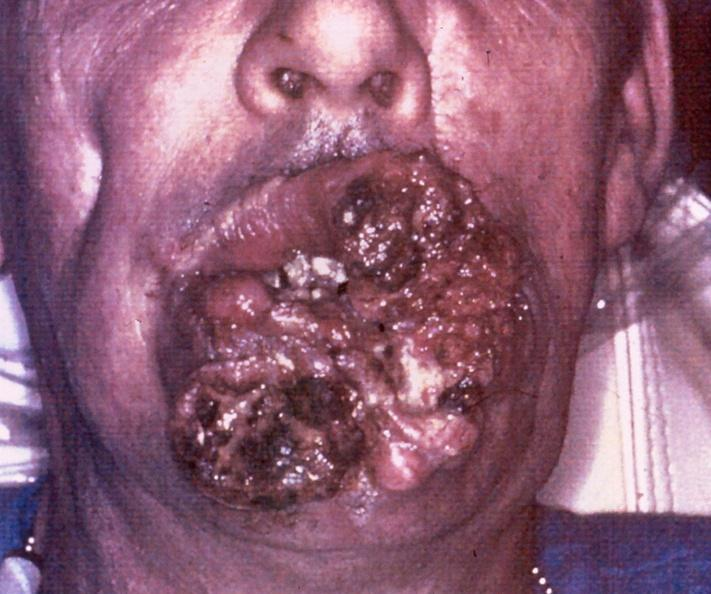s gastrointestinal present?
Answer the question using a single word or phrase. Yes 